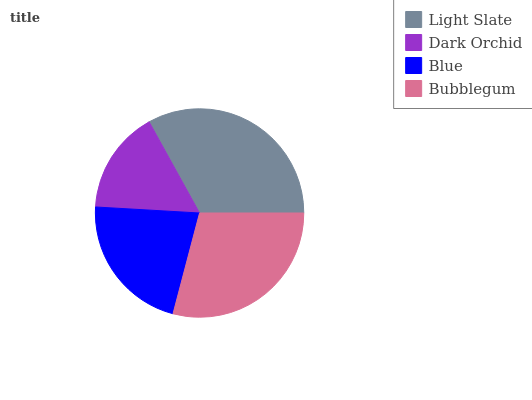Is Dark Orchid the minimum?
Answer yes or no. Yes. Is Light Slate the maximum?
Answer yes or no. Yes. Is Blue the minimum?
Answer yes or no. No. Is Blue the maximum?
Answer yes or no. No. Is Blue greater than Dark Orchid?
Answer yes or no. Yes. Is Dark Orchid less than Blue?
Answer yes or no. Yes. Is Dark Orchid greater than Blue?
Answer yes or no. No. Is Blue less than Dark Orchid?
Answer yes or no. No. Is Bubblegum the high median?
Answer yes or no. Yes. Is Blue the low median?
Answer yes or no. Yes. Is Blue the high median?
Answer yes or no. No. Is Light Slate the low median?
Answer yes or no. No. 